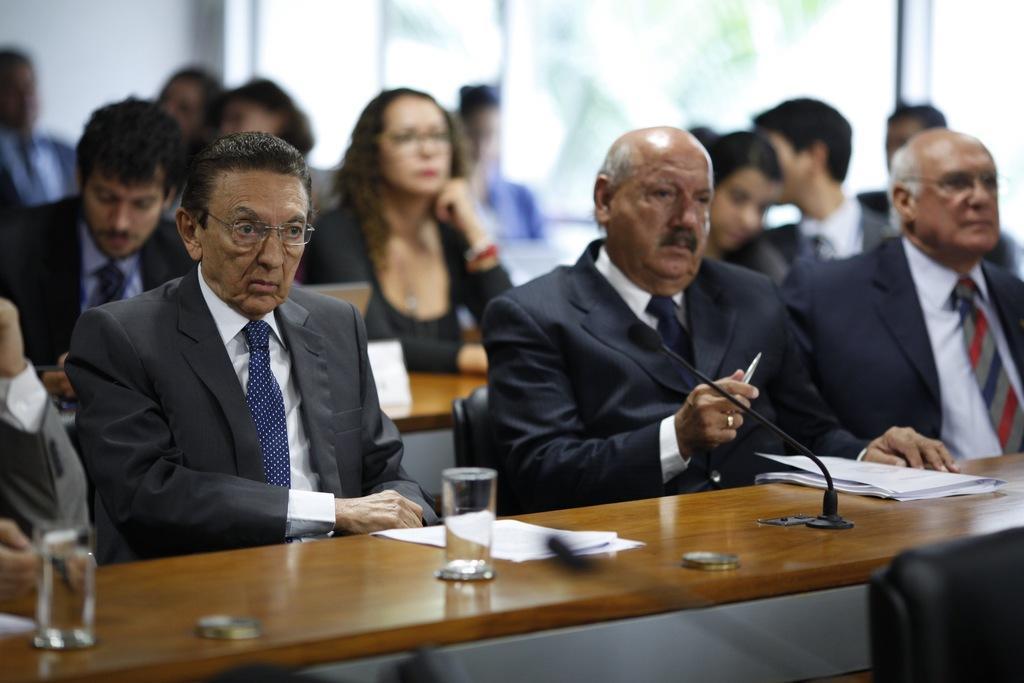Could you give a brief overview of what you see in this image? In this image there are people sitting on the chair, there is a desk, there are objects on the desk, there is a microphone, there is a person holding an object, there is a wall, the background of the image is blurred. 